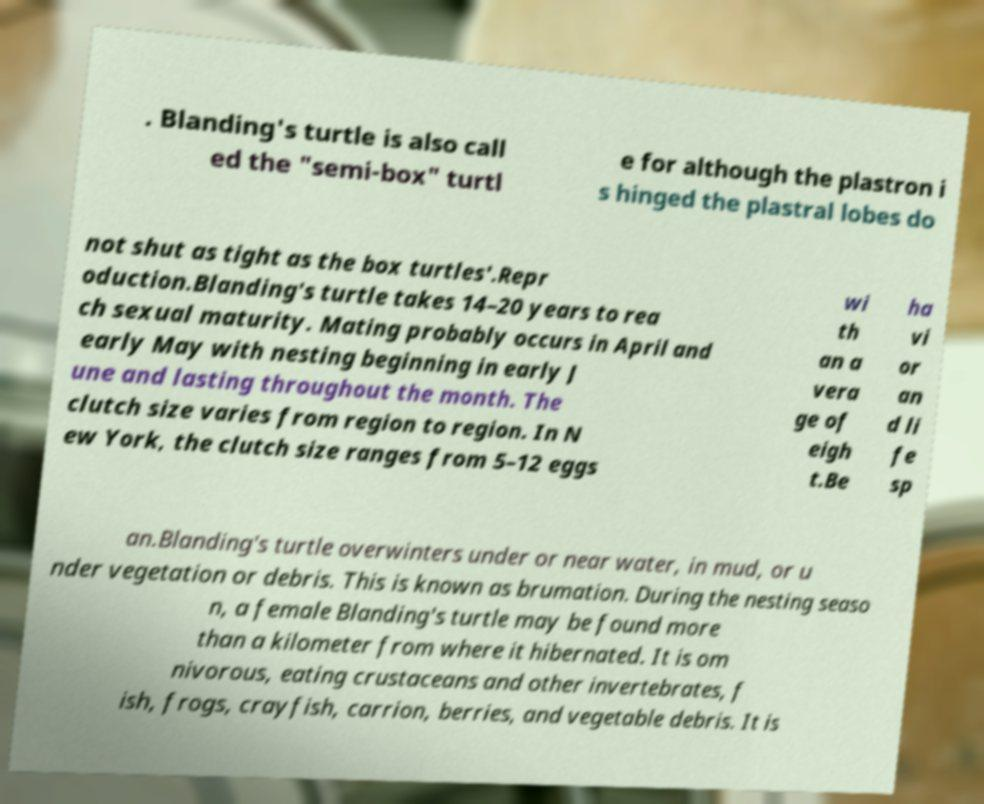What messages or text are displayed in this image? I need them in a readable, typed format. . Blanding's turtle is also call ed the "semi-box" turtl e for although the plastron i s hinged the plastral lobes do not shut as tight as the box turtles'.Repr oduction.Blanding's turtle takes 14–20 years to rea ch sexual maturity. Mating probably occurs in April and early May with nesting beginning in early J une and lasting throughout the month. The clutch size varies from region to region. In N ew York, the clutch size ranges from 5–12 eggs wi th an a vera ge of eigh t.Be ha vi or an d li fe sp an.Blanding's turtle overwinters under or near water, in mud, or u nder vegetation or debris. This is known as brumation. During the nesting seaso n, a female Blanding's turtle may be found more than a kilometer from where it hibernated. It is om nivorous, eating crustaceans and other invertebrates, f ish, frogs, crayfish, carrion, berries, and vegetable debris. It is 